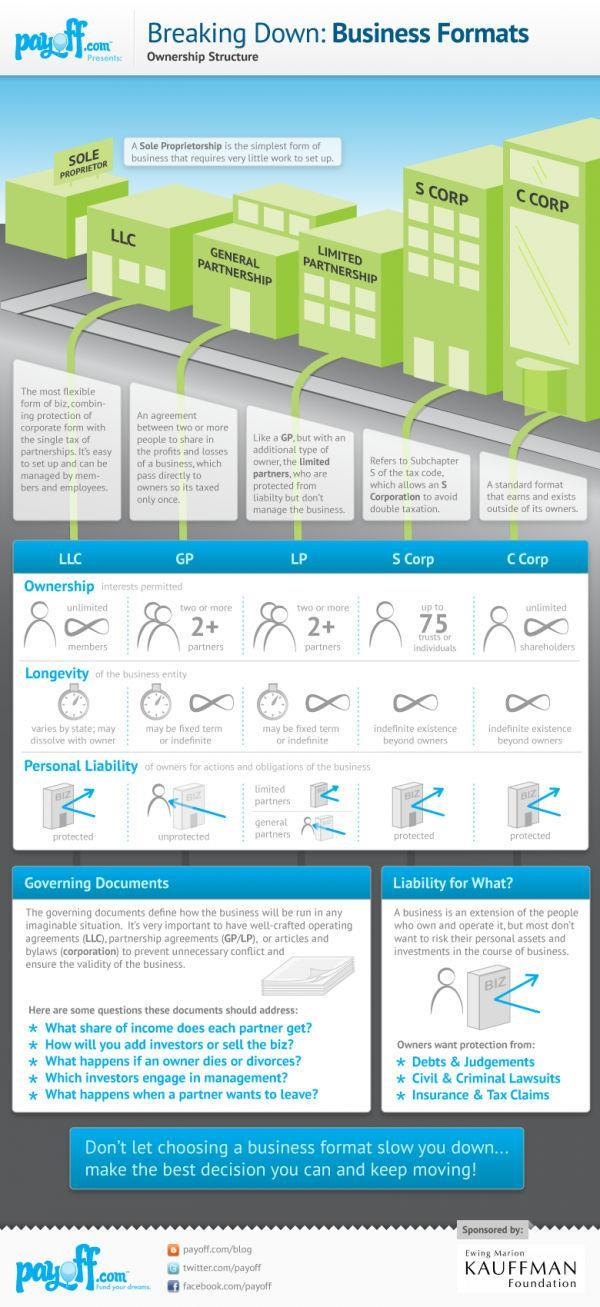Which types of ownership structure provides protected personal liability of owners?
Answer the question with a short phrase. LLC, S Corp, C Corp In which types of ownership the business has maximum life? S Corp, C Corp Which types of ownership has two or more than two partners? Limited Partnership, General Partnership How many ownership structures are listed ? 6 